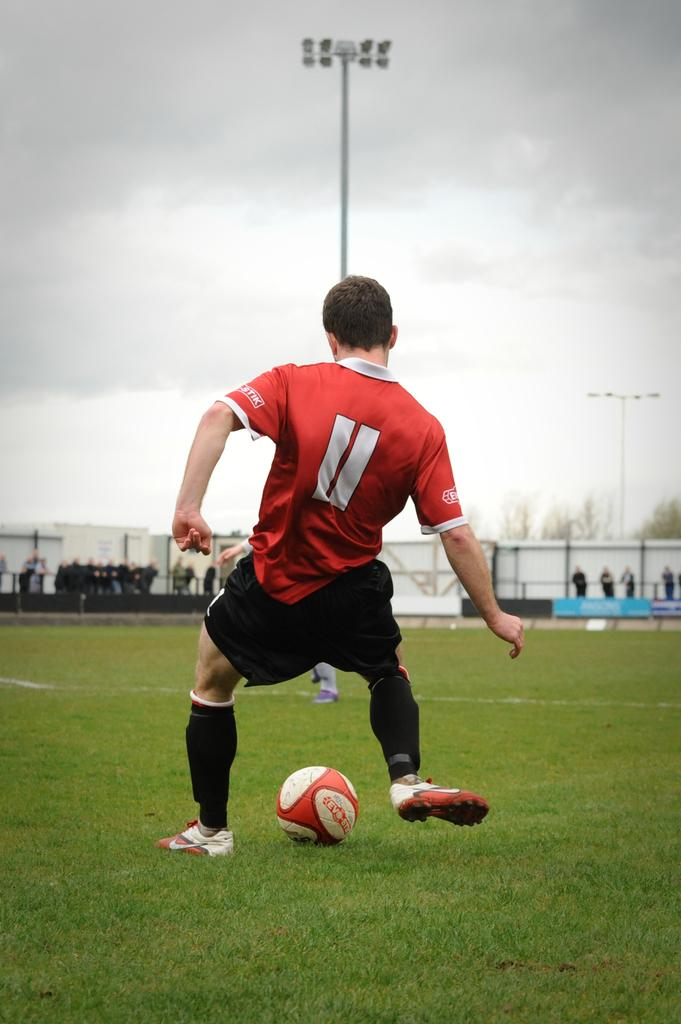<image>
Describe the image concisely. Number 11 or the red team, prepares to kick the soccer ball. 